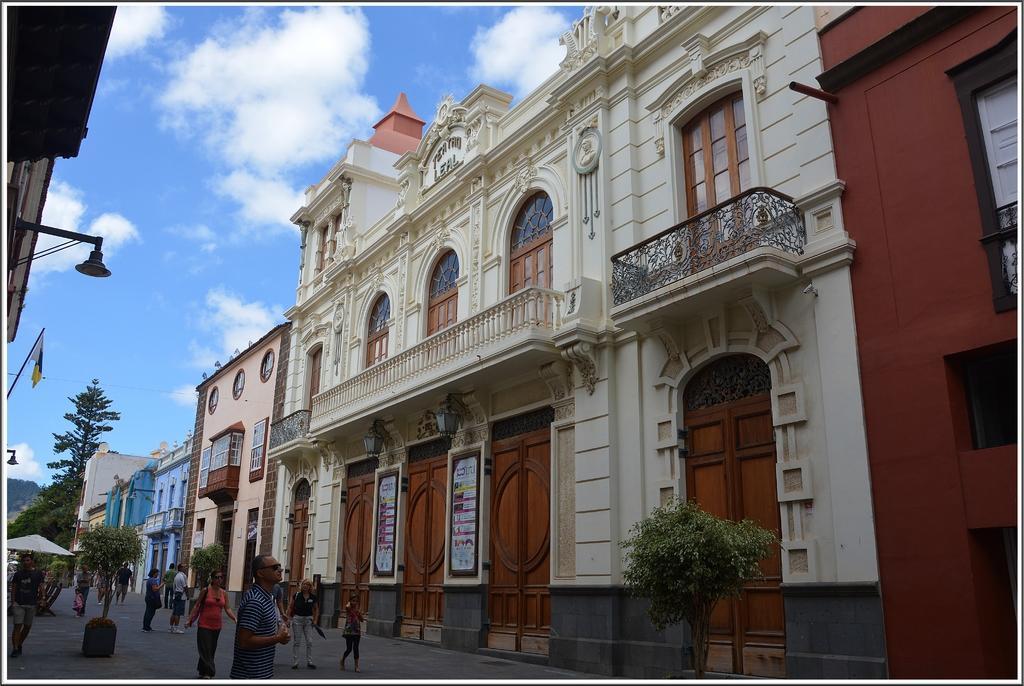How would you summarize this image in a sentence or two? In this image there are people walking on a road, on either side of the road there are plants, in the background there are buildings, trees and the sky, in the top left there is a roof and light and a flag. 